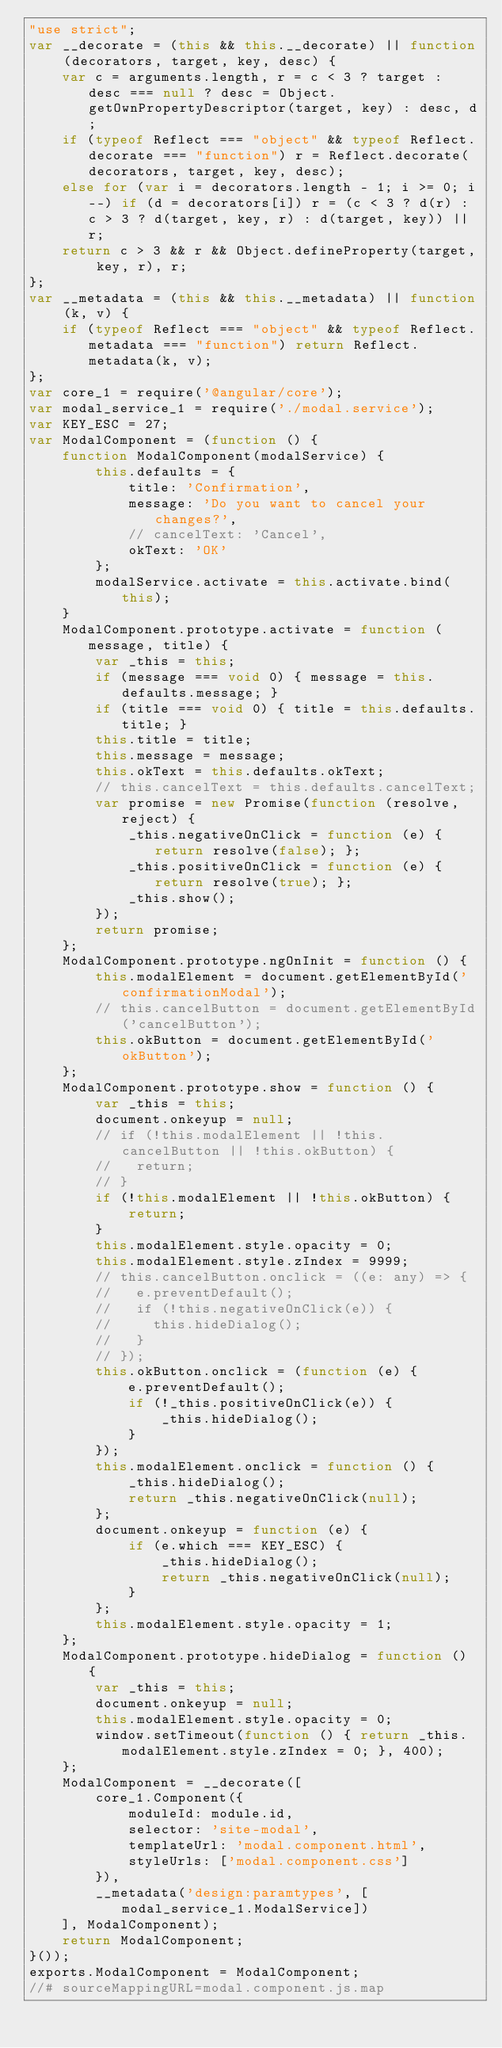Convert code to text. <code><loc_0><loc_0><loc_500><loc_500><_JavaScript_>"use strict";
var __decorate = (this && this.__decorate) || function (decorators, target, key, desc) {
    var c = arguments.length, r = c < 3 ? target : desc === null ? desc = Object.getOwnPropertyDescriptor(target, key) : desc, d;
    if (typeof Reflect === "object" && typeof Reflect.decorate === "function") r = Reflect.decorate(decorators, target, key, desc);
    else for (var i = decorators.length - 1; i >= 0; i--) if (d = decorators[i]) r = (c < 3 ? d(r) : c > 3 ? d(target, key, r) : d(target, key)) || r;
    return c > 3 && r && Object.defineProperty(target, key, r), r;
};
var __metadata = (this && this.__metadata) || function (k, v) {
    if (typeof Reflect === "object" && typeof Reflect.metadata === "function") return Reflect.metadata(k, v);
};
var core_1 = require('@angular/core');
var modal_service_1 = require('./modal.service');
var KEY_ESC = 27;
var ModalComponent = (function () {
    function ModalComponent(modalService) {
        this.defaults = {
            title: 'Confirmation',
            message: 'Do you want to cancel your changes?',
            // cancelText: 'Cancel',
            okText: 'OK'
        };
        modalService.activate = this.activate.bind(this);
    }
    ModalComponent.prototype.activate = function (message, title) {
        var _this = this;
        if (message === void 0) { message = this.defaults.message; }
        if (title === void 0) { title = this.defaults.title; }
        this.title = title;
        this.message = message;
        this.okText = this.defaults.okText;
        // this.cancelText = this.defaults.cancelText;
        var promise = new Promise(function (resolve, reject) {
            _this.negativeOnClick = function (e) { return resolve(false); };
            _this.positiveOnClick = function (e) { return resolve(true); };
            _this.show();
        });
        return promise;
    };
    ModalComponent.prototype.ngOnInit = function () {
        this.modalElement = document.getElementById('confirmationModal');
        // this.cancelButton = document.getElementById('cancelButton');
        this.okButton = document.getElementById('okButton');
    };
    ModalComponent.prototype.show = function () {
        var _this = this;
        document.onkeyup = null;
        // if (!this.modalElement || !this.cancelButton || !this.okButton) {
        //   return;
        // }
        if (!this.modalElement || !this.okButton) {
            return;
        }
        this.modalElement.style.opacity = 0;
        this.modalElement.style.zIndex = 9999;
        // this.cancelButton.onclick = ((e: any) => {
        //   e.preventDefault();
        //   if (!this.negativeOnClick(e)) {
        //     this.hideDialog();
        //   }
        // });
        this.okButton.onclick = (function (e) {
            e.preventDefault();
            if (!_this.positiveOnClick(e)) {
                _this.hideDialog();
            }
        });
        this.modalElement.onclick = function () {
            _this.hideDialog();
            return _this.negativeOnClick(null);
        };
        document.onkeyup = function (e) {
            if (e.which === KEY_ESC) {
                _this.hideDialog();
                return _this.negativeOnClick(null);
            }
        };
        this.modalElement.style.opacity = 1;
    };
    ModalComponent.prototype.hideDialog = function () {
        var _this = this;
        document.onkeyup = null;
        this.modalElement.style.opacity = 0;
        window.setTimeout(function () { return _this.modalElement.style.zIndex = 0; }, 400);
    };
    ModalComponent = __decorate([
        core_1.Component({
            moduleId: module.id,
            selector: 'site-modal',
            templateUrl: 'modal.component.html',
            styleUrls: ['modal.component.css']
        }), 
        __metadata('design:paramtypes', [modal_service_1.ModalService])
    ], ModalComponent);
    return ModalComponent;
}());
exports.ModalComponent = ModalComponent;
//# sourceMappingURL=modal.component.js.map</code> 